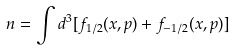<formula> <loc_0><loc_0><loc_500><loc_500>n = \int d ^ { 3 } [ f _ { 1 / 2 } ( x , p ) + f _ { - 1 / 2 } ( x , p ) ]</formula> 